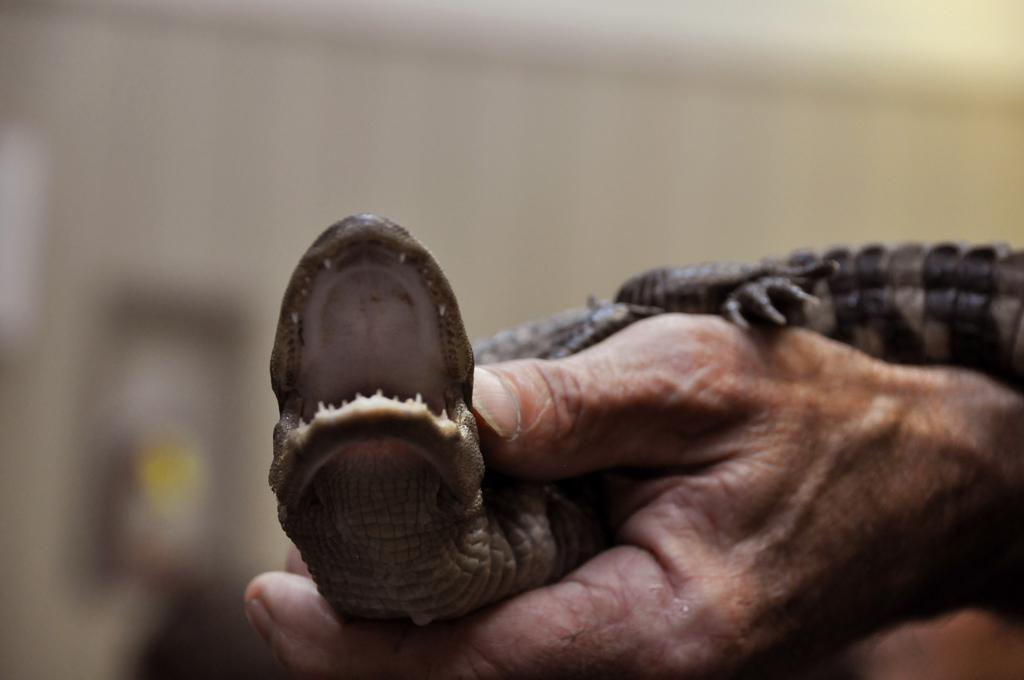How would you summarize this image in a sentence or two? In this image we can see there is a person's hand holding a reptile and at the back it looks like a blur. 